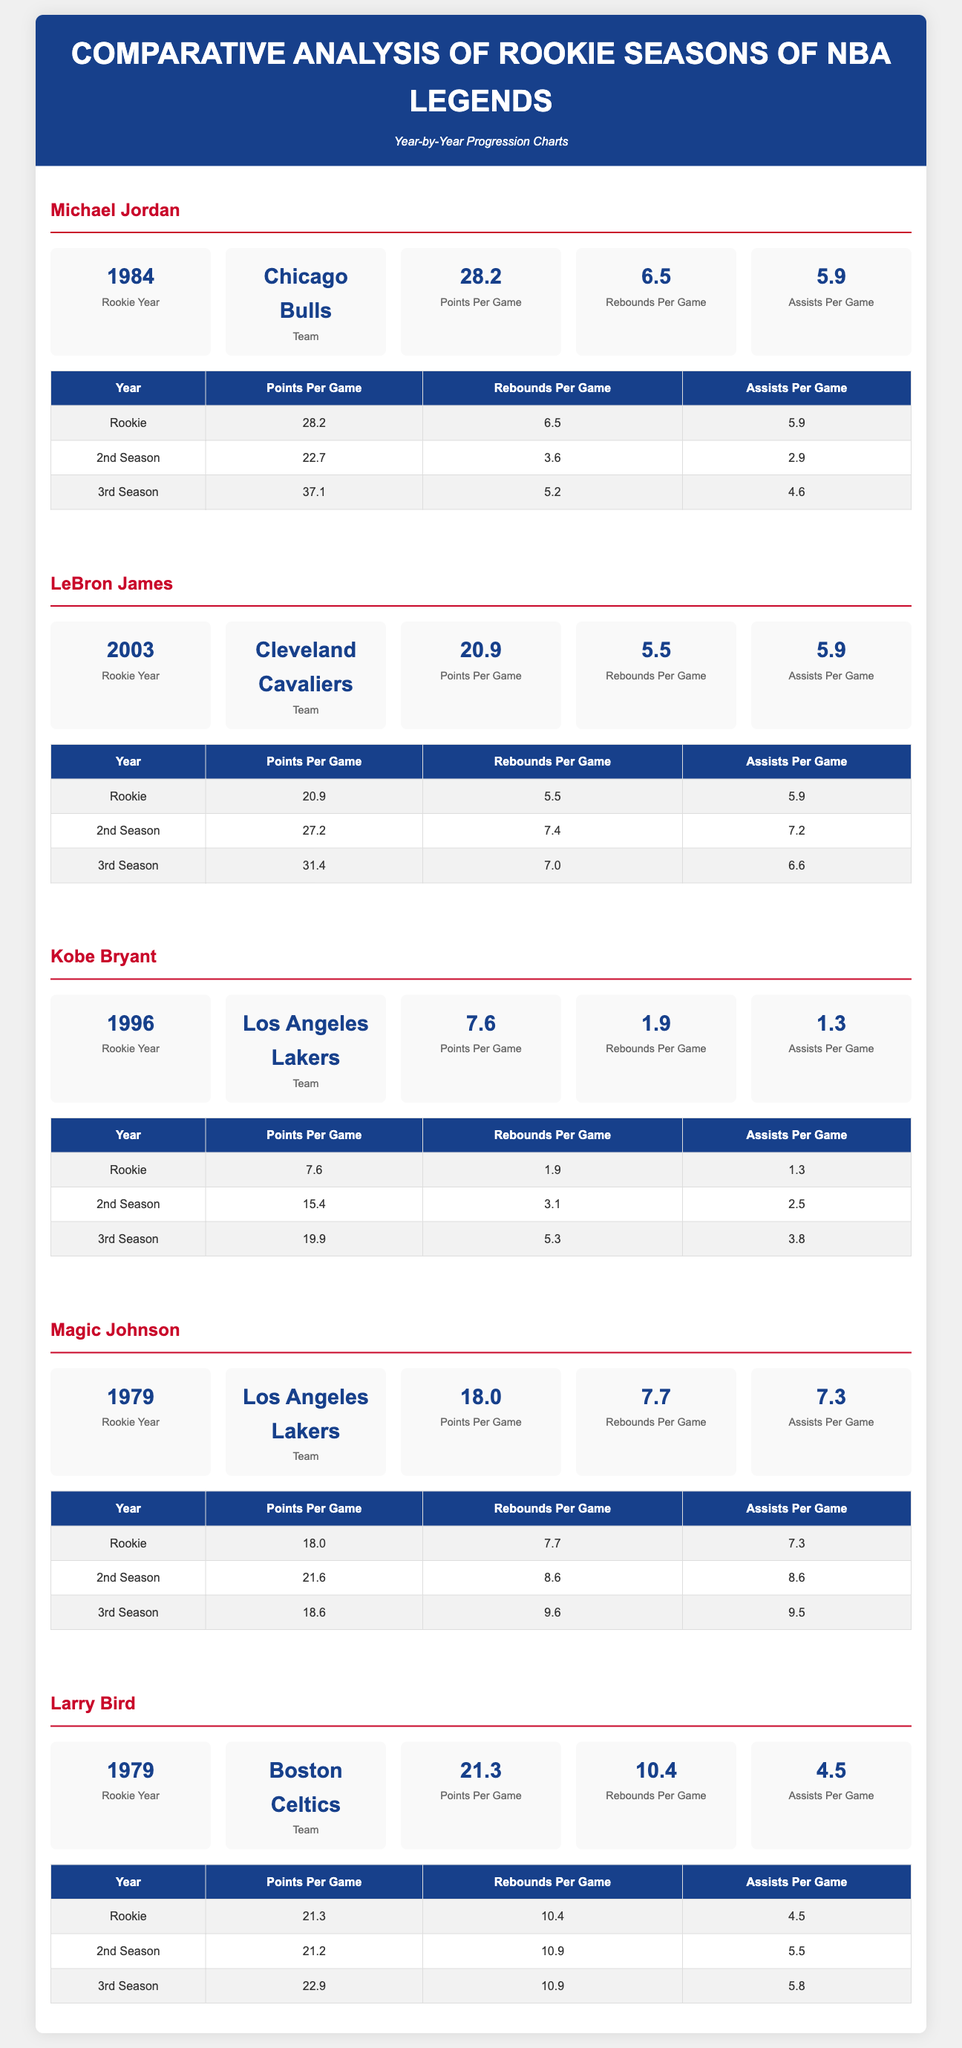What year did Michael Jordan start his rookie season? The document states that Michael Jordan's rookie year was 1984.
Answer: 1984 What team did LeBron James play for in his rookie season? According to the document, LeBron James played for the Cleveland Cavaliers in his rookie season.
Answer: Cleveland Cavaliers How many points per game did Kobe Bryant score in his rookie season? The document indicates that Kobe Bryant scored 7.6 points per game during his rookie season.
Answer: 7.6 Which player had the highest rebounds per game in their rookie season? By comparing the statistics, Magic Johnson had the highest rebounds per game at 7.7.
Answer: Magic Johnson In which year did Larry Bird start his NBA career? The document shows that Larry Bird's rookie year was 1979.
Answer: 1979 Which player experienced the highest points per game increase from their rookie to second season? Assessing the data, LeBron James increased from 20.9 points per game to 27.2 points per game, showing the greatest improvement.
Answer: LeBron James How many assists per game did Magic Johnson have in his second season? The document provides that Magic Johnson had 8.6 assists per game in his second season.
Answer: 8.6 What was the average points per game for Michael Jordan over his first three years? Calculating the average: (28.2 + 22.7 + 37.1) / 3 = 29.367, rounded to 29.4.
Answer: 29.4 Which player had the lowest points per game in their rookie season? Through the data, Kobe Bryant had the lowest points per game in his rookie season with 7.6.
Answer: Kobe Bryant 